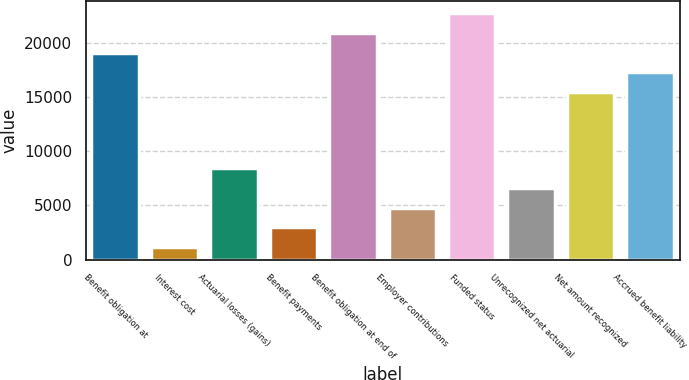<chart> <loc_0><loc_0><loc_500><loc_500><bar_chart><fcel>Benefit obligation at<fcel>Interest cost<fcel>Actuarial losses (gains)<fcel>Benefit payments<fcel>Benefit obligation at end of<fcel>Employer contributions<fcel>Funded status<fcel>Unrecognized net actuarial<fcel>Net amount recognized<fcel>Accrued benefit liability<nl><fcel>19098.8<fcel>1142<fcel>8451.6<fcel>2969.4<fcel>20926.2<fcel>4796.8<fcel>22753.6<fcel>6624.2<fcel>15444<fcel>17271.4<nl></chart> 